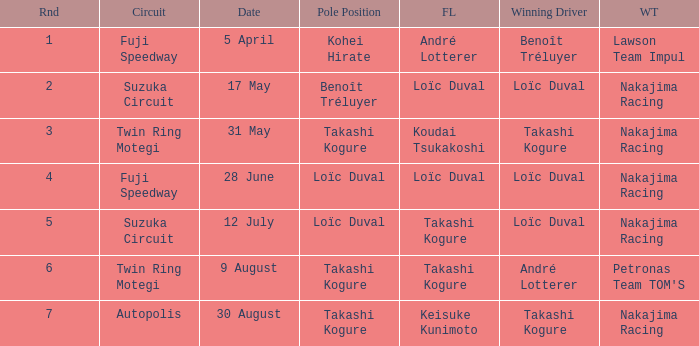How many drivers drove on Suzuka Circuit where Loïc Duval took pole position? 1.0. 